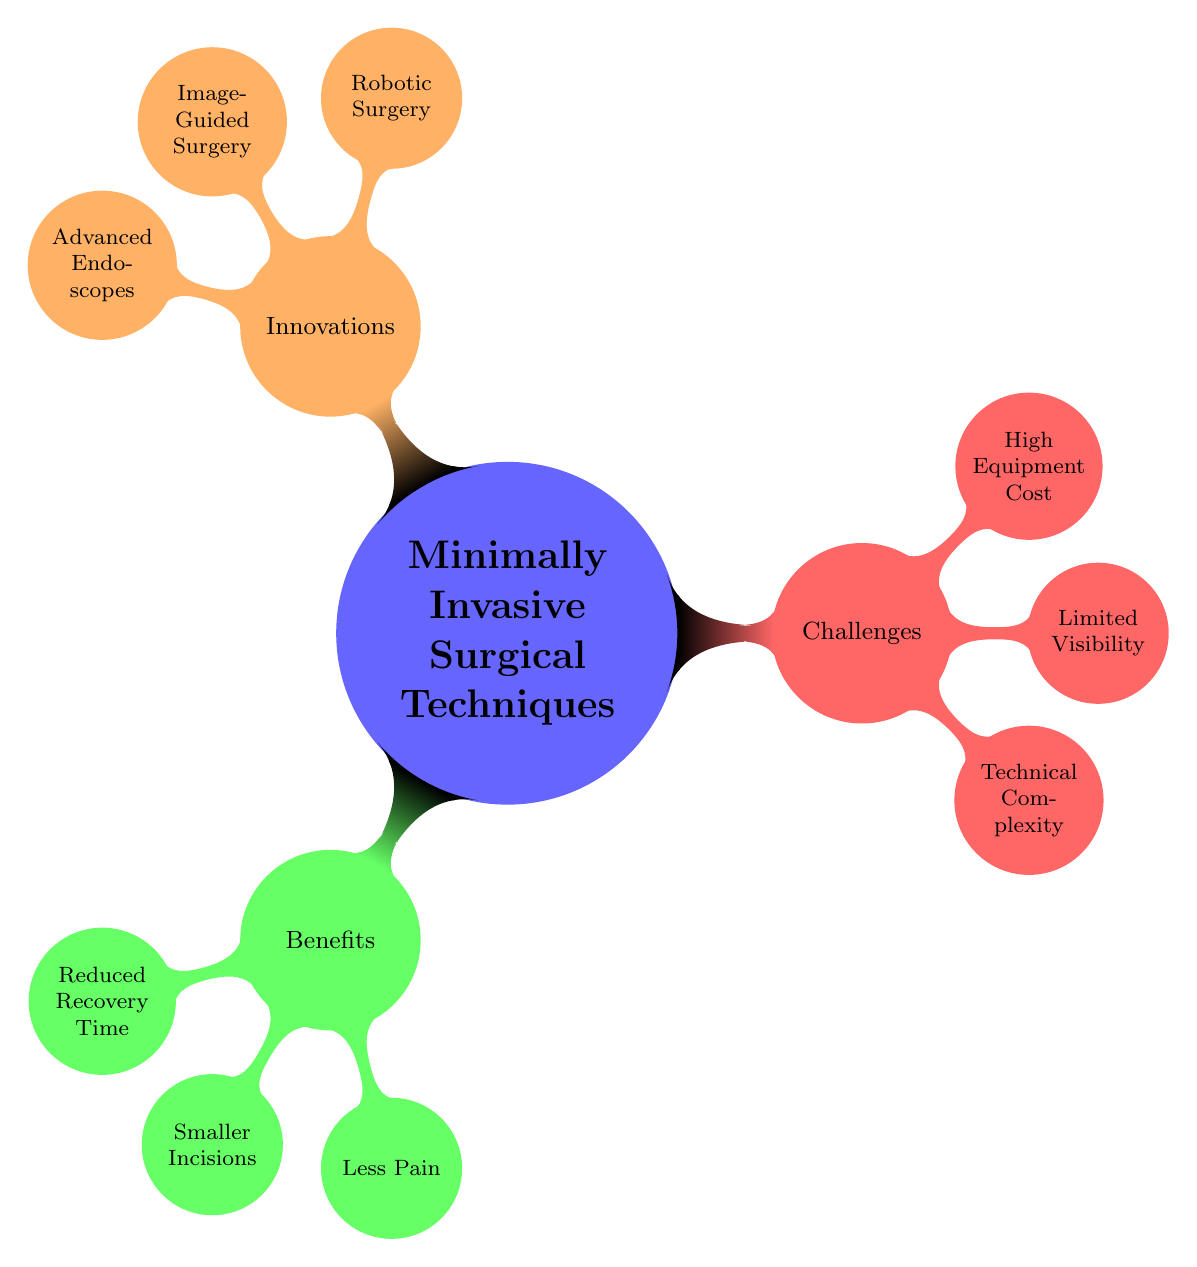What are the primary benefits of minimally invasive surgical techniques? The diagram lists three main benefits: Reduced Recovery Time, Smaller Incisions, and Less Pain, under the 'Benefits' node.
Answer: Reduced Recovery Time, Smaller Incisions, Less Pain How many challenges are identified in the diagram? The 'Challenges' node contains three specific challenges: Technical Complexity, Limited Visibility, and High Equipment Cost. Therefore, the total number is three.
Answer: 3 Which innovation involves surgical robots? The 'Innovations' node includes Robotic Surgery, which specifically mentions the da Vinci Surgical System as an example of this technology.
Answer: Robotic Surgery What is the relationship between 'Technical Complexity' and 'Minimally Invasive Surgical Techniques'? 'Technical Complexity' is a challenge listed under the Challenges node, which demonstrates a negative aspect affecting the implementation of Minimally Invasive Surgical Techniques.
Answer: Challenge Which benefit suggests less postoperative pain? The benefit described as Less Pain directly indicates a reduction in postoperative discomfort and the need for pain medication.
Answer: Less Pain How is Advanced Endoscopes categorized in the diagram? Advanced Endoscopes is positioned under the Innovations node, showing its role as a technological advancement in the context of Minimally Invasive Surgical Techniques.
Answer: Innovations What does the 'High Equipment Cost' signify in this context? 'High Equipment Cost' is categorized as a challenge, indicating a financial obstacle in accessing the necessary tools or devices for minimally invasive surgical procedures.
Answer: Challenge Which technique enhances precision through imaging? The technique mentioned under Innovations is Image-Guided Surgery, which utilizes MRI and CT scans for enhanced precision in minimally invasive operations.
Answer: Image-Guided Surgery 